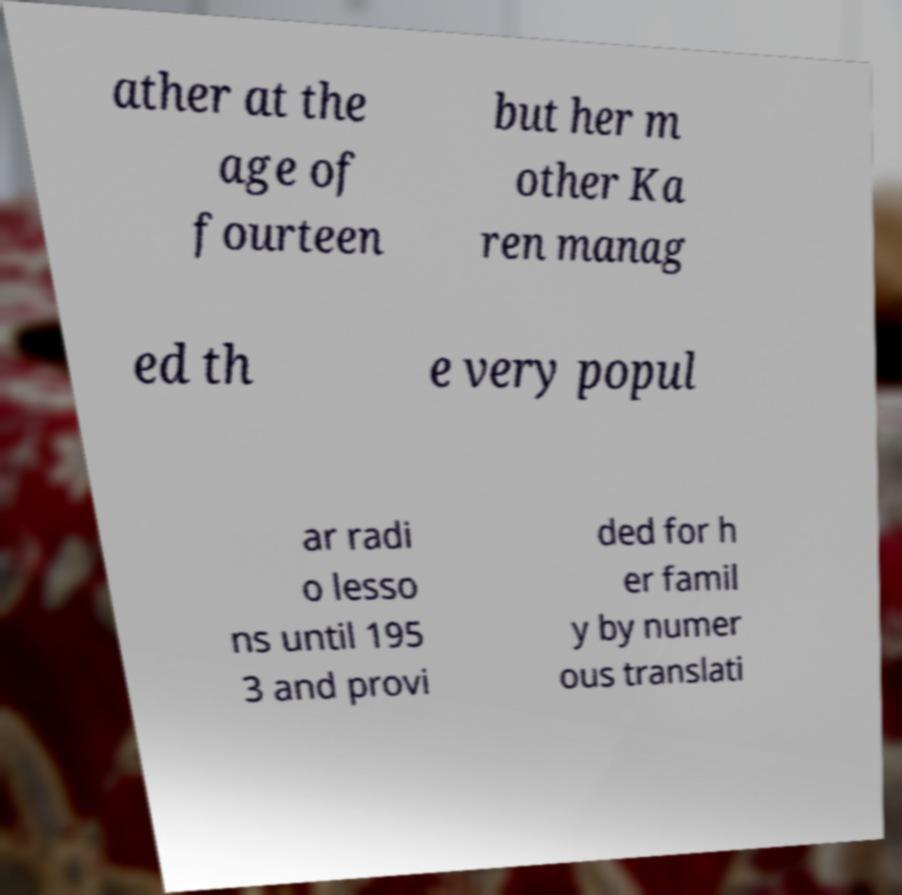For documentation purposes, I need the text within this image transcribed. Could you provide that? ather at the age of fourteen but her m other Ka ren manag ed th e very popul ar radi o lesso ns until 195 3 and provi ded for h er famil y by numer ous translati 